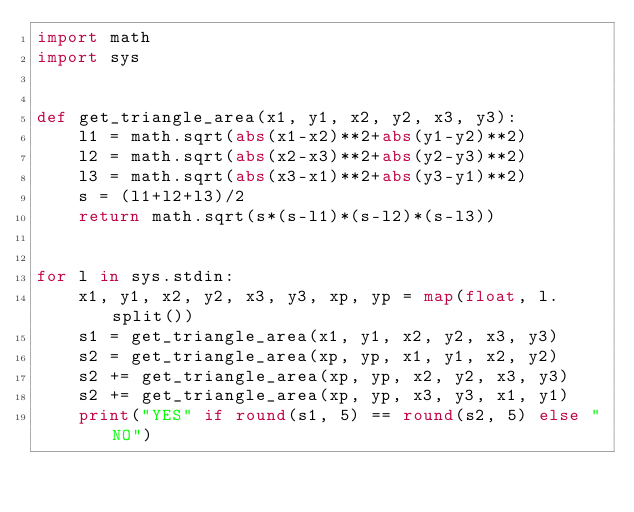Convert code to text. <code><loc_0><loc_0><loc_500><loc_500><_Python_>import math
import sys


def get_triangle_area(x1, y1, x2, y2, x3, y3):
    l1 = math.sqrt(abs(x1-x2)**2+abs(y1-y2)**2)
    l2 = math.sqrt(abs(x2-x3)**2+abs(y2-y3)**2)
    l3 = math.sqrt(abs(x3-x1)**2+abs(y3-y1)**2)
    s = (l1+l2+l3)/2
    return math.sqrt(s*(s-l1)*(s-l2)*(s-l3))


for l in sys.stdin:
    x1, y1, x2, y2, x3, y3, xp, yp = map(float, l.split())
    s1 = get_triangle_area(x1, y1, x2, y2, x3, y3)
    s2 = get_triangle_area(xp, yp, x1, y1, x2, y2)
    s2 += get_triangle_area(xp, yp, x2, y2, x3, y3)
    s2 += get_triangle_area(xp, yp, x3, y3, x1, y1)
    print("YES" if round(s1, 5) == round(s2, 5) else "NO")</code> 